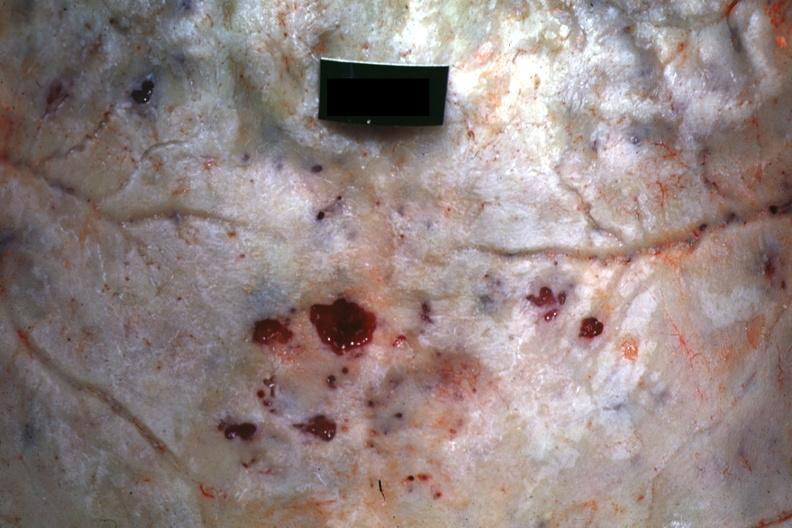s bone, skull present?
Answer the question using a single word or phrase. Yes 